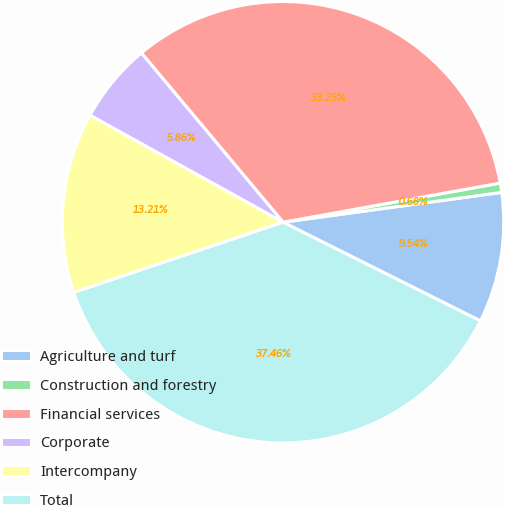Convert chart. <chart><loc_0><loc_0><loc_500><loc_500><pie_chart><fcel>Agriculture and turf<fcel>Construction and forestry<fcel>Financial services<fcel>Corporate<fcel>Intercompany<fcel>Total<nl><fcel>9.54%<fcel>0.68%<fcel>33.25%<fcel>5.86%<fcel>13.21%<fcel>37.46%<nl></chart> 